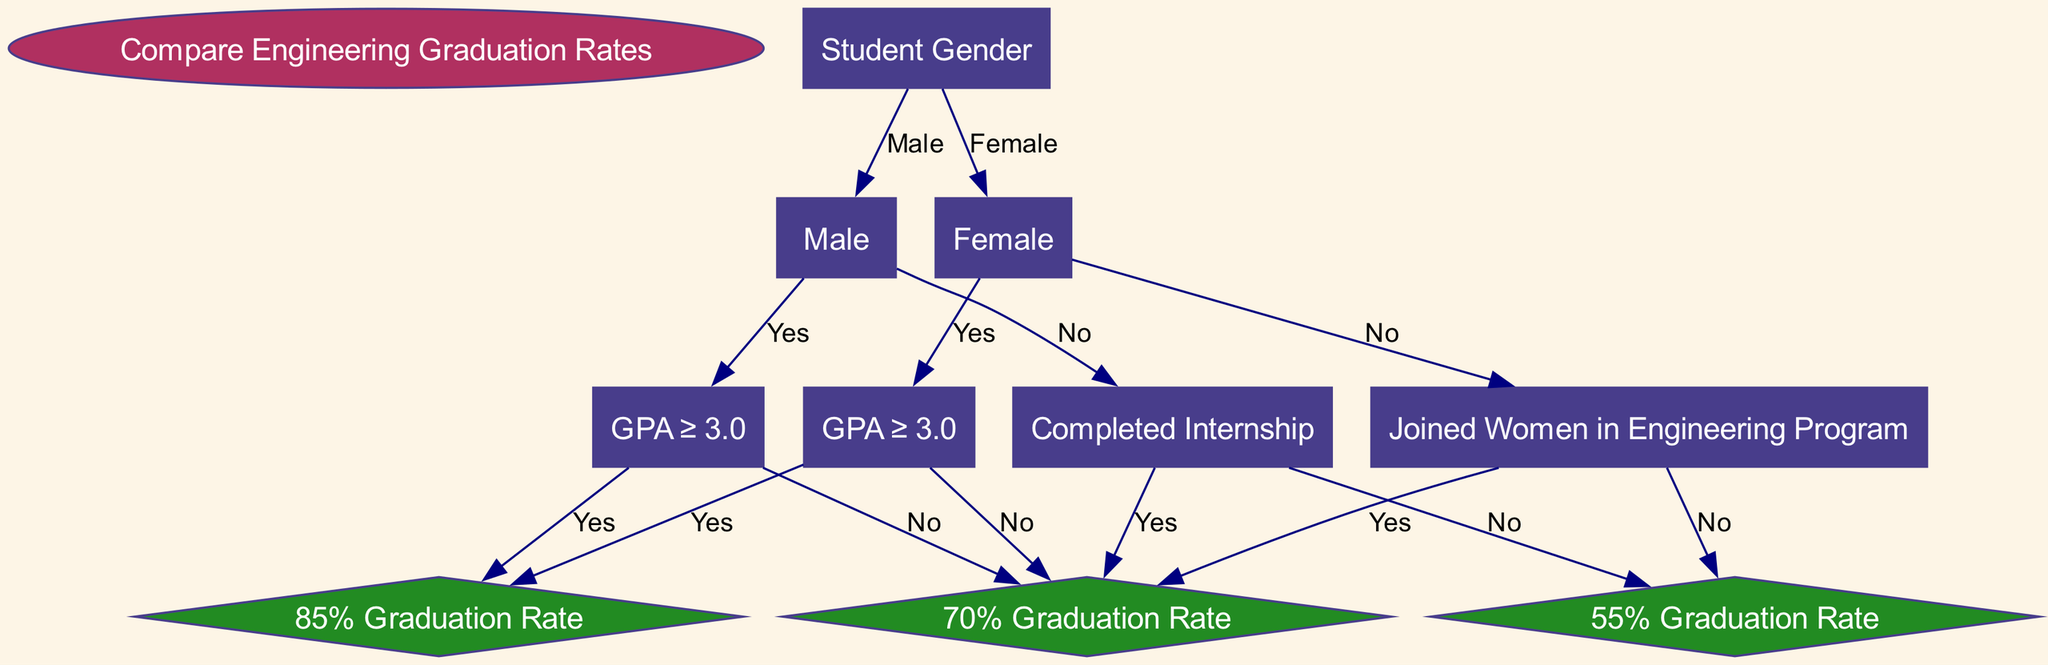What is the root node of this decision tree? The root node is labeled "Compare Engineering Graduation Rates". This is the starting point of the decision tree from where comparisons are made.
Answer: Compare Engineering Graduation Rates How many nodes are in the diagram? The nodes in the diagram include the root and gender nodes, as well as performance-related nodes for both male and female students, totaling six nodes.
Answer: 6 What is the graduation rate for female students who have a GPA of 3.0 or higher? The path for female students with a GPA of 3.0 or higher leads to the outcome labeled "85% Graduation Rate". Therefore, this is the graduation rate for that group.
Answer: 85% Graduation Rate What outcome is reached if a male student does not complete an internship? Following the decision tree, if a male student does not complete an internship, the flow leads to "low graduation rate". Thus, this is the outcome for that scenario.
Answer: 55% Graduation Rate Which program is associated with female students who had a lower graduation rate? The diagram indicates that if female students do not join the "Women in Engineering Program", they are directed to a medium graduation rate. This sponsorship could have beneficial effects.
Answer: Women in Engineering Program What is the graduation rate for male students who have a GPA below 3.0? The path for those who do not meet the GPA requirement leads to "low graduation rate", indicating poor outcomes for this category of students.
Answer: 55% Graduation Rate What are the two paths to reach a "medium graduation rate" for male students? The diagram shows two paths: one where a male student has a GPA lower than 3.0 and the other where he completes an internship. In both cases, the outcome is a "medium graduation rate".
Answer: GPA < 3.0 and Internship Completed Which gender is associated with more favorable graduation rates overall? Examining the paths for graduation rates, female students consistently show a higher graduation rate of 85% compared to male students, indicating better outcomes.
Answer: Female What decision leads to the highest graduation rate for male students? To achieve the highest graduation rate, a male student must have a GPA of 3.0 or higher. This group's outcome is marked as "85% Graduation Rate".
Answer: GPA ≥ 3.0 